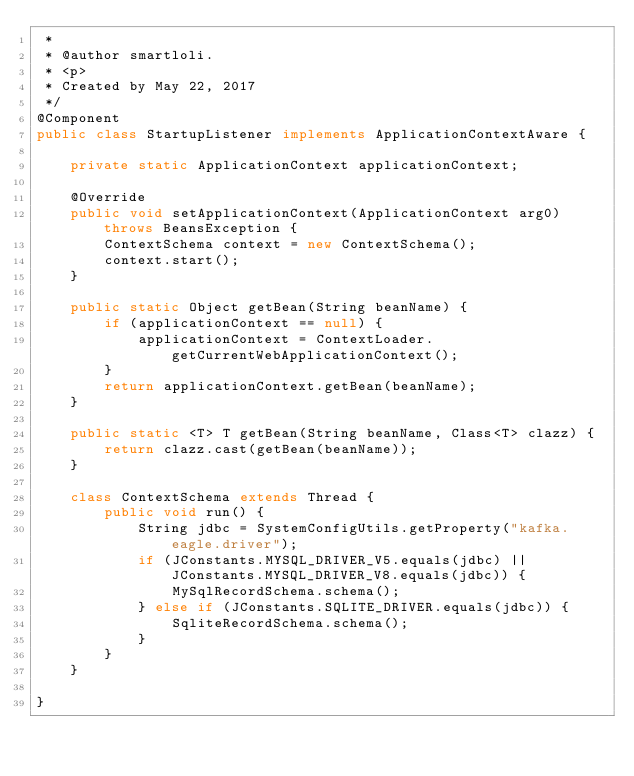<code> <loc_0><loc_0><loc_500><loc_500><_Java_> *
 * @author smartloli.
 * <p>
 * Created by May 22, 2017
 */
@Component
public class StartupListener implements ApplicationContextAware {

    private static ApplicationContext applicationContext;

    @Override
    public void setApplicationContext(ApplicationContext arg0) throws BeansException {
        ContextSchema context = new ContextSchema();
        context.start();
    }

    public static Object getBean(String beanName) {
        if (applicationContext == null) {
            applicationContext = ContextLoader.getCurrentWebApplicationContext();
        }
        return applicationContext.getBean(beanName);
    }

    public static <T> T getBean(String beanName, Class<T> clazz) {
        return clazz.cast(getBean(beanName));
    }

    class ContextSchema extends Thread {
        public void run() {
            String jdbc = SystemConfigUtils.getProperty("kafka.eagle.driver");
            if (JConstants.MYSQL_DRIVER_V5.equals(jdbc) || JConstants.MYSQL_DRIVER_V8.equals(jdbc)) {
                MySqlRecordSchema.schema();
            } else if (JConstants.SQLITE_DRIVER.equals(jdbc)) {
                SqliteRecordSchema.schema();
            }
        }
    }

}
</code> 